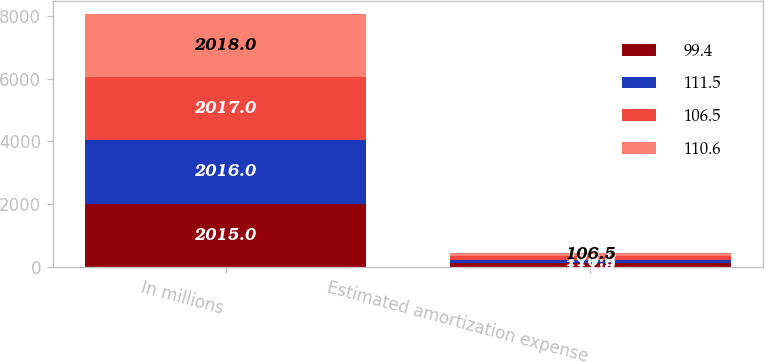Convert chart. <chart><loc_0><loc_0><loc_500><loc_500><stacked_bar_chart><ecel><fcel>In millions<fcel>Estimated amortization expense<nl><fcel>99.4<fcel>2015<fcel>111.5<nl><fcel>111.5<fcel>2016<fcel>110.6<nl><fcel>106.5<fcel>2017<fcel>109<nl><fcel>110.6<fcel>2018<fcel>106.5<nl></chart> 